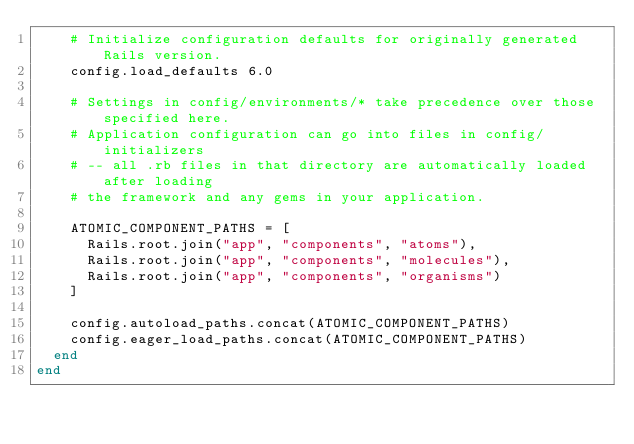Convert code to text. <code><loc_0><loc_0><loc_500><loc_500><_Ruby_>    # Initialize configuration defaults for originally generated Rails version.
    config.load_defaults 6.0

    # Settings in config/environments/* take precedence over those specified here.
    # Application configuration can go into files in config/initializers
    # -- all .rb files in that directory are automatically loaded after loading
    # the framework and any gems in your application.

    ATOMIC_COMPONENT_PATHS = [
      Rails.root.join("app", "components", "atoms"),
      Rails.root.join("app", "components", "molecules"),
      Rails.root.join("app", "components", "organisms")
    ]

    config.autoload_paths.concat(ATOMIC_COMPONENT_PATHS)
    config.eager_load_paths.concat(ATOMIC_COMPONENT_PATHS)
  end
end

</code> 